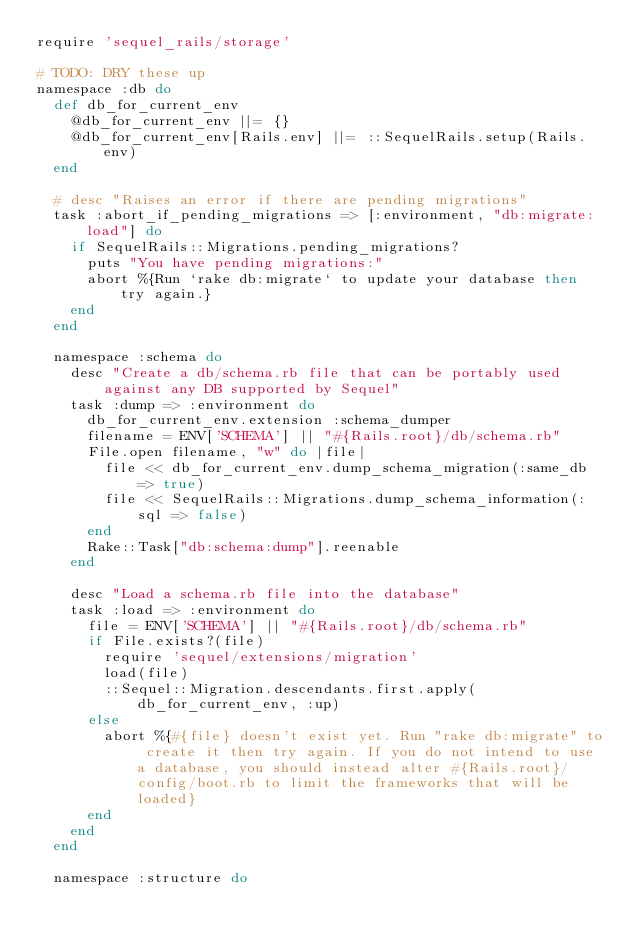<code> <loc_0><loc_0><loc_500><loc_500><_Ruby_>require 'sequel_rails/storage'

# TODO: DRY these up
namespace :db do
  def db_for_current_env
    @db_for_current_env ||= {}
    @db_for_current_env[Rails.env] ||= ::SequelRails.setup(Rails.env)
  end

  # desc "Raises an error if there are pending migrations"
  task :abort_if_pending_migrations => [:environment, "db:migrate:load"] do
    if SequelRails::Migrations.pending_migrations?
      puts "You have pending migrations:"
      abort %{Run `rake db:migrate` to update your database then try again.}
    end
  end

  namespace :schema do
    desc "Create a db/schema.rb file that can be portably used against any DB supported by Sequel"
    task :dump => :environment do
      db_for_current_env.extension :schema_dumper
      filename = ENV['SCHEMA'] || "#{Rails.root}/db/schema.rb"
      File.open filename, "w" do |file|
        file << db_for_current_env.dump_schema_migration(:same_db => true)
        file << SequelRails::Migrations.dump_schema_information(:sql => false)
      end
      Rake::Task["db:schema:dump"].reenable
    end

    desc "Load a schema.rb file into the database"
    task :load => :environment do
      file = ENV['SCHEMA'] || "#{Rails.root}/db/schema.rb"
      if File.exists?(file)
        require 'sequel/extensions/migration'
        load(file)
        ::Sequel::Migration.descendants.first.apply(db_for_current_env, :up)
      else
        abort %{#{file} doesn't exist yet. Run "rake db:migrate" to create it then try again. If you do not intend to use a database, you should instead alter #{Rails.root}/config/boot.rb to limit the frameworks that will be loaded}
      end
    end
  end

  namespace :structure do</code> 